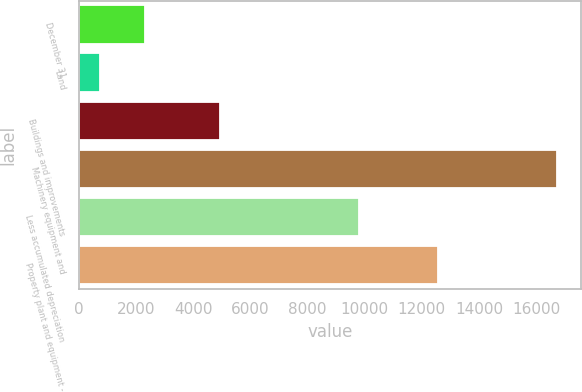Convert chart to OTSL. <chart><loc_0><loc_0><loc_500><loc_500><bar_chart><fcel>December 31<fcel>Land<fcel>Buildings and improvements<fcel>Machinery equipment and<fcel>Less accumulated depreciation<fcel>Property plant and equipment -<nl><fcel>2317.6<fcel>717<fcel>4914<fcel>16723<fcel>9783<fcel>12571<nl></chart> 